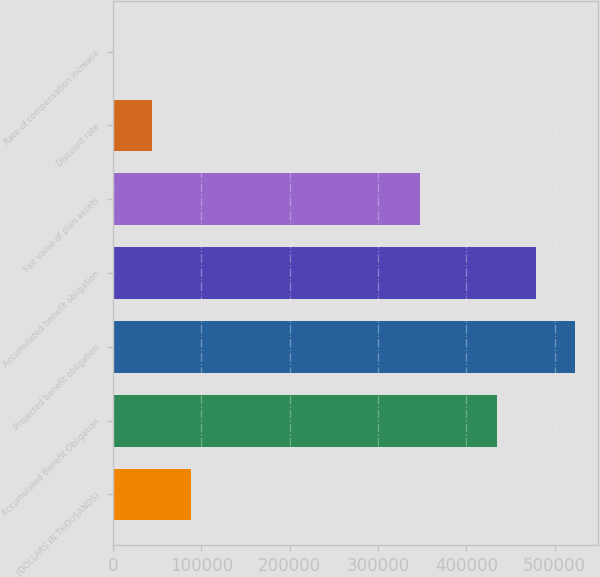Convert chart. <chart><loc_0><loc_0><loc_500><loc_500><bar_chart><fcel>(DOLLARS IN THOUSANDS)<fcel>Accumulated Benefit Obligation<fcel>Projected benefit obligation<fcel>Accumulated benefit obligation<fcel>Fair value of plan assets<fcel>Discount rate<fcel>Rate of compensation increase<nl><fcel>88131.8<fcel>435123<fcel>523252<fcel>479187<fcel>347084<fcel>44067.5<fcel>3.25<nl></chart> 